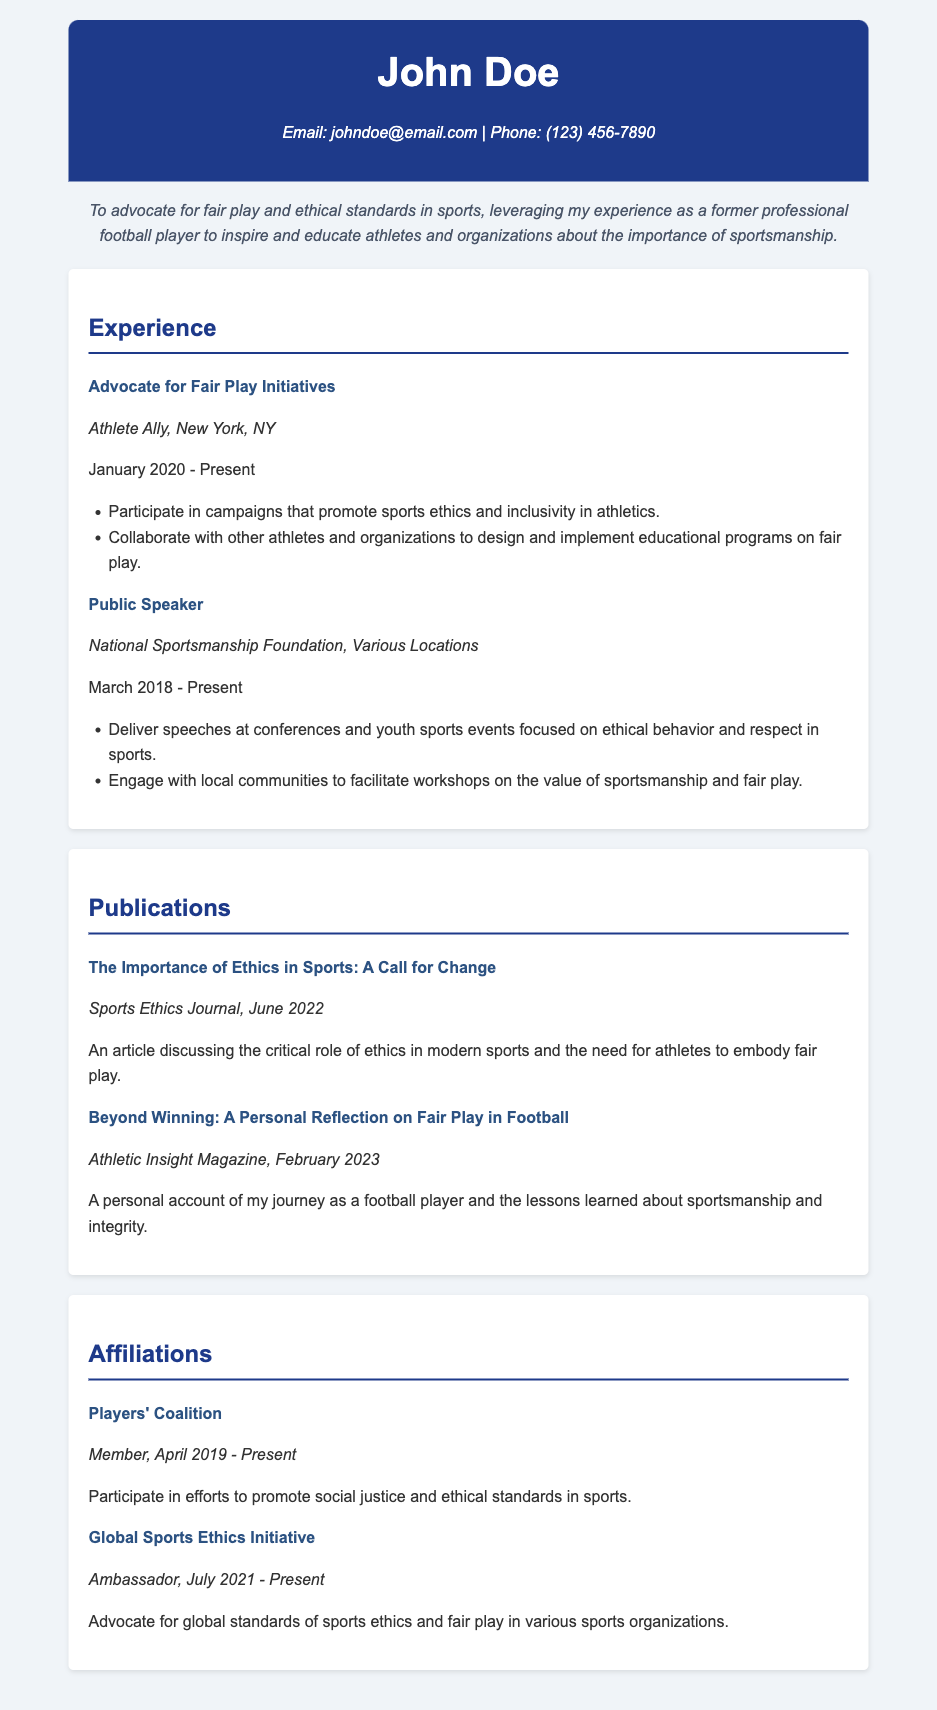What is the name of the individual in the CV? The individual's name is located at the top of the document, where it states "John Doe."
Answer: John Doe What organization is John Doe affiliated with as an advocate for fair play initiatives? This information is found in the experience section, where it mentions "Athlete Ally" as the organization.
Answer: Athlete Ally In what year did John Doe start his role as a public speaker? The start date is specified in the experience section for public speaking, which states "March 2018."
Answer: March 2018 What is the title of the article published in the Sports Ethics Journal? The title can be found under the publications section, which states "The Importance of Ethics in Sports: A Call for Change."
Answer: The Importance of Ethics in Sports: A Call for Change Which organization does John Doe serve as an ambassador? This is found in the affiliations section where it states "Global Sports Ethics Initiative."
Answer: Global Sports Ethics Initiative What is a primary focus of the campaigns John Doe participates in? The experience section mentions that the campaigns focus on "sports ethics and inclusivity in athletics."
Answer: sports ethics and inclusivity How many publications are listed in the CV? By counting the items in the publications section, it can be determined that there are two listed publications.
Answer: Two What role does John Doe hold in the Players' Coalition? The affiliation section specifies that he is a "Member" of the Players' Coalition.
Answer: Member What is stated in the objective of the CV? The objective section outlines his aim to "advocate for fair play and ethical standards in sports."
Answer: advocate for fair play and ethical standards in sports 